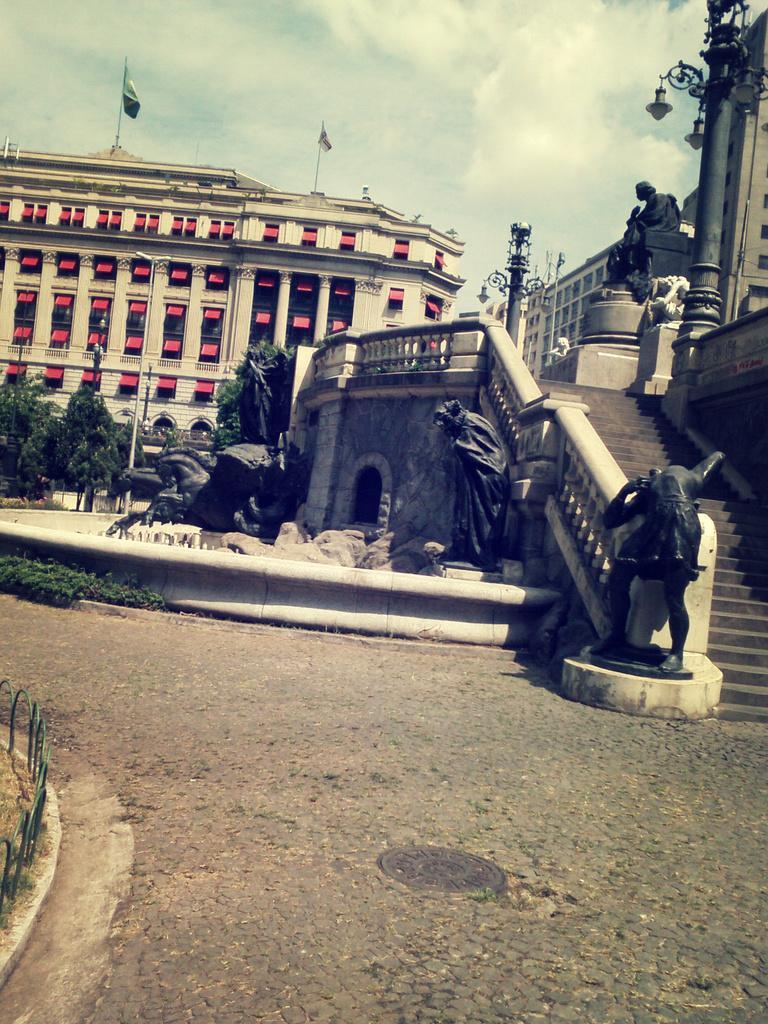Can you describe this image briefly? In this image, we can see some sculptures and steps. There are flags on the building which is in the middle of the image. There are some trees on the left side of the image. There is a pole in the top right of the image. There is a sky at the top of the image. 